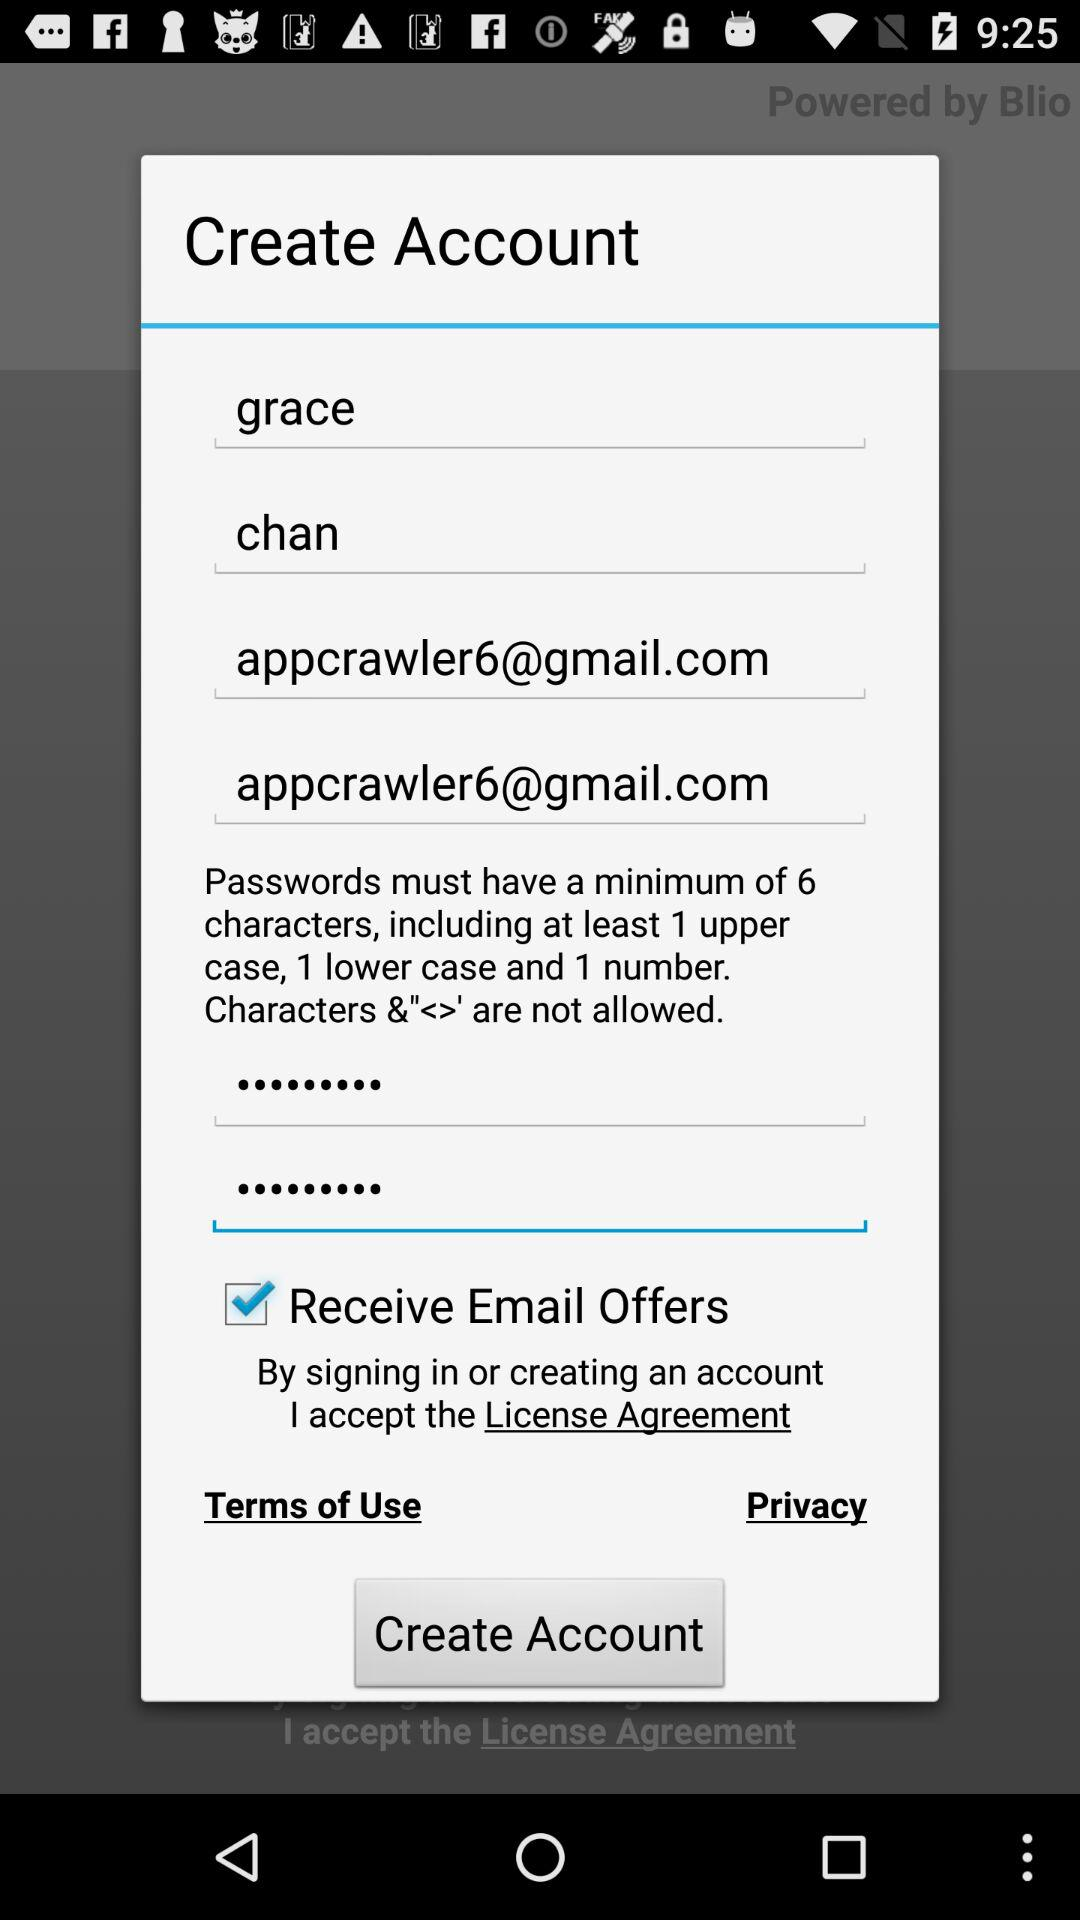What is the email address? The email address is appcrawler6@gmail.com. 